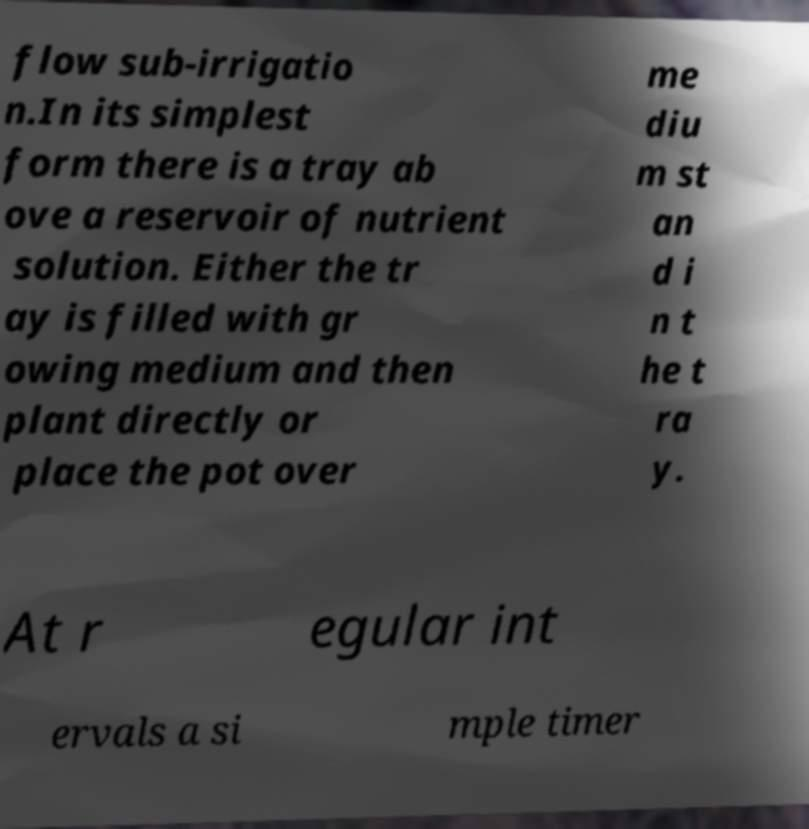There's text embedded in this image that I need extracted. Can you transcribe it verbatim? flow sub-irrigatio n.In its simplest form there is a tray ab ove a reservoir of nutrient solution. Either the tr ay is filled with gr owing medium and then plant directly or place the pot over me diu m st an d i n t he t ra y. At r egular int ervals a si mple timer 